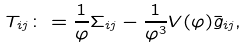Convert formula to latex. <formula><loc_0><loc_0><loc_500><loc_500>T _ { i j } \colon = \frac { 1 } { \varphi } \Sigma _ { i j } - \frac { 1 } { \varphi ^ { 3 } } V \/ ( \varphi ) \bar { g } _ { i j } ,</formula> 